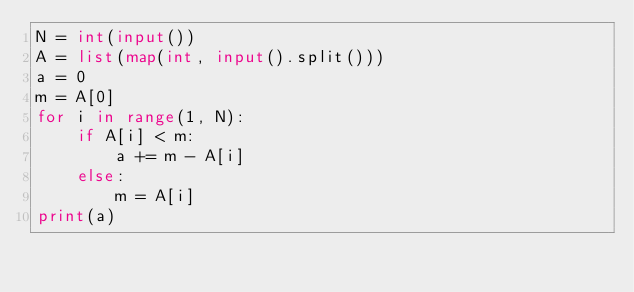<code> <loc_0><loc_0><loc_500><loc_500><_Python_>N = int(input())
A = list(map(int, input().split()))
a = 0
m = A[0]
for i in range(1, N):
    if A[i] < m:
        a += m - A[i]
    else:
        m = A[i]
print(a)</code> 